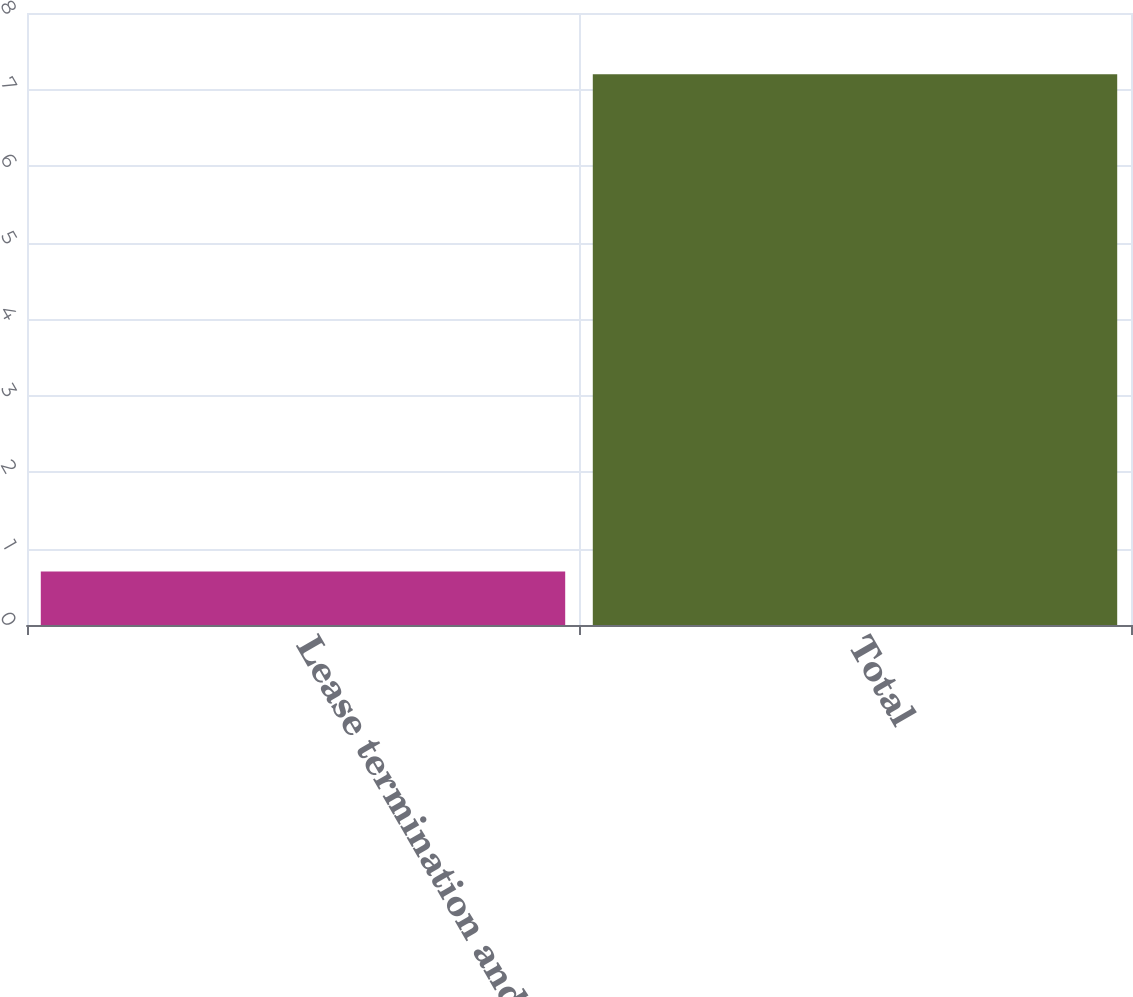Convert chart. <chart><loc_0><loc_0><loc_500><loc_500><bar_chart><fcel>Lease termination and asset<fcel>Total<nl><fcel>0.7<fcel>7.2<nl></chart> 